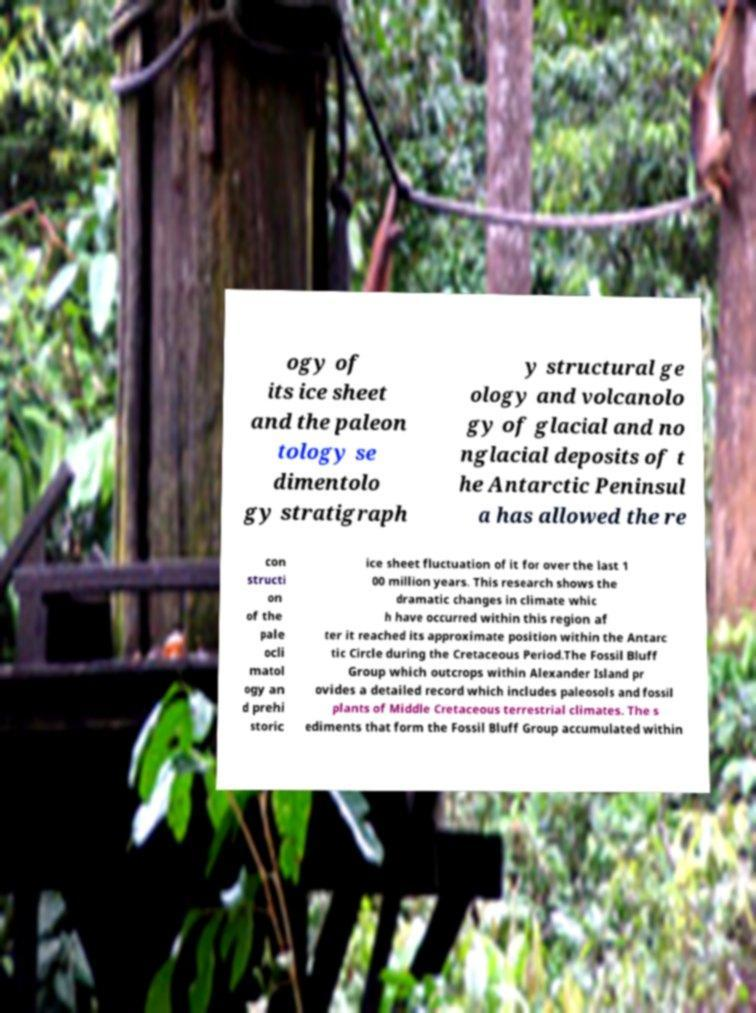I need the written content from this picture converted into text. Can you do that? ogy of its ice sheet and the paleon tology se dimentolo gy stratigraph y structural ge ology and volcanolo gy of glacial and no nglacial deposits of t he Antarctic Peninsul a has allowed the re con structi on of the pale ocli matol ogy an d prehi storic ice sheet fluctuation of it for over the last 1 00 million years. This research shows the dramatic changes in climate whic h have occurred within this region af ter it reached its approximate position within the Antarc tic Circle during the Cretaceous Period.The Fossil Bluff Group which outcrops within Alexander Island pr ovides a detailed record which includes paleosols and fossil plants of Middle Cretaceous terrestrial climates. The s ediments that form the Fossil Bluff Group accumulated within 